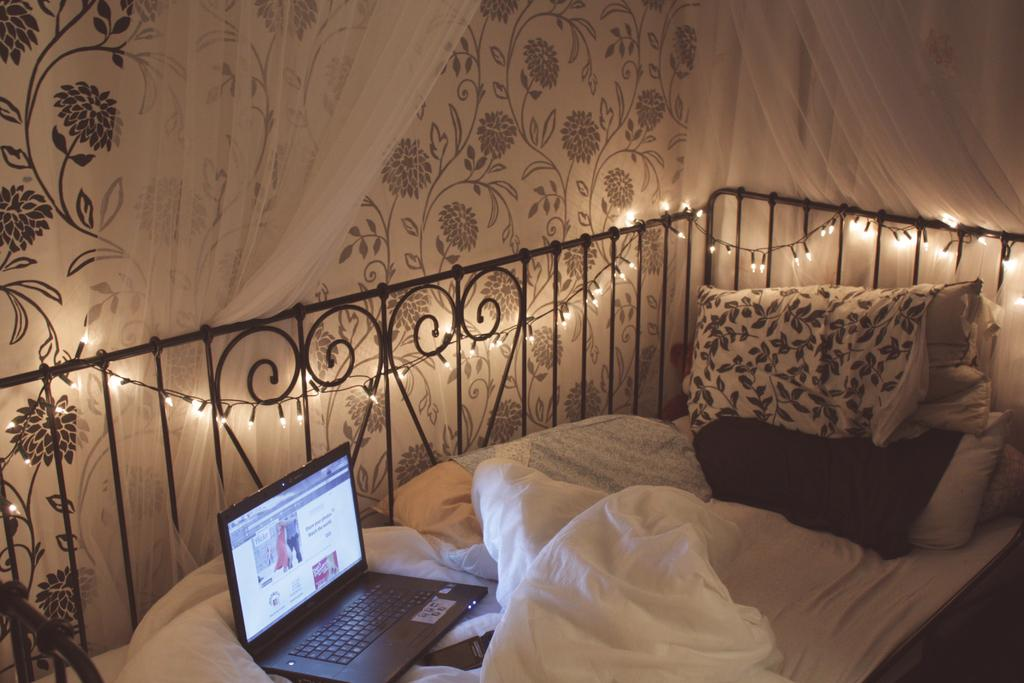What type of furniture is visible in the image? There are pillows and a bed-sheet visible in the image, which suggests a bed. What electronic device can be seen on the bed? There is a laptop on the bed in the image. What type of lighting is present in the image? There are lights near the wall in the image. What is visible in the top right corner of the image? There is a cloth visible in the top right corner of the image. What type of soap is being used by the dad in the image? There is no dad present in the image, and therefore no soap usage can be observed. How does the acoustics of the room affect the sound of the laptop in the image? The provided facts do not mention anything about the acoustics of the room, so it cannot be determined how they might affect the sound of the laptop. 